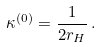Convert formula to latex. <formula><loc_0><loc_0><loc_500><loc_500>\kappa ^ { ( 0 ) } = \frac { 1 } { 2 r _ { H } } \, .</formula> 